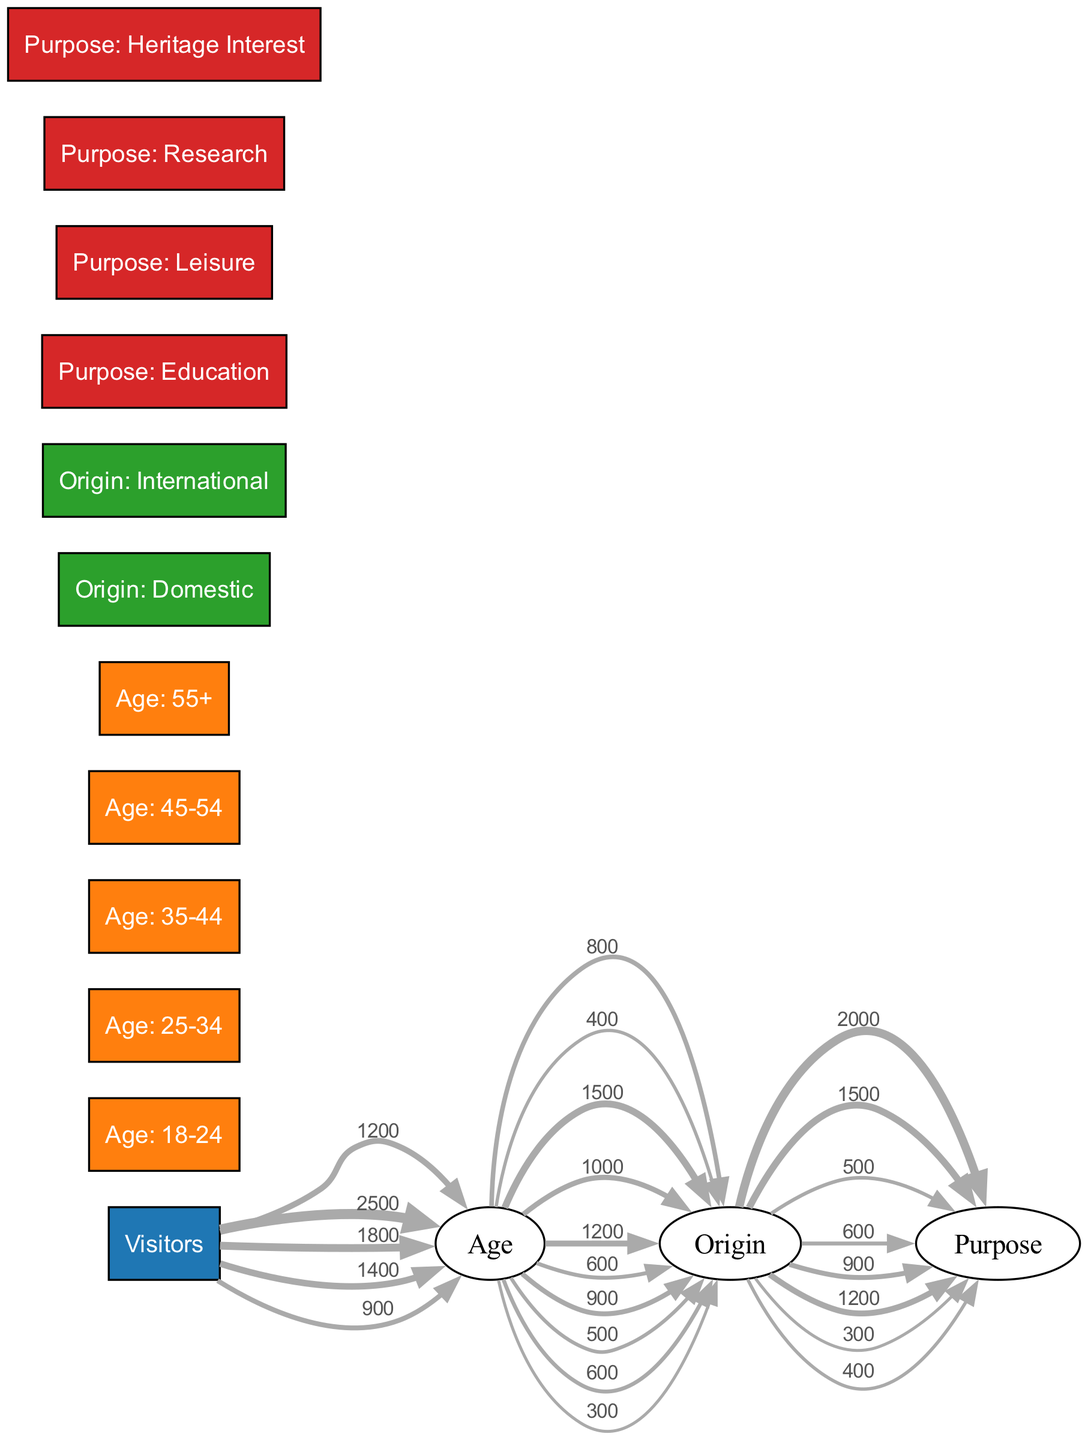What is the total number of visitors aged 25-34? The diagram shows a direct flow from the node "Visitors" to "Age: 25-34" with a value of 2500, indicating that this is the total number of visitors in this age range.
Answer: 2500 Which age group has the lowest number of visitors? By comparing the values linked to each age group node, "Age: 55+" has a value of 900, which is the smallest of all age groups.
Answer: Age: 55+ What percentage of visitors aged 18-24 are domestic? The node "Age: 18-24" has a split flow of 800 to "Origin: Domestic" and 400 to "Origin: International". Therefore, the percentage of domestic visitors in this age group is (800 / 1200) * 100 = 66.67%.
Answer: 66.67% What is the total number of visitors from international origin? Summing all visitors flowing from "Origin: International" gives 400 + 1000 + 600 + 500 = 2800, indicating that this is the total number of visitors from international origins.
Answer: 2800 Which purpose of visit is most common for domestic visitors? The highest value for the purpose of domestic visitors is "Purpose: Education" with a value of 2000, indicating that it is the most common purpose.
Answer: Purpose: Education What is the total value of all purposes for international visitors? Adding the values from "Origin: International" yields 900 + 1200 + 300 + 400 = 2800, indicating this is the total for all purposes of international visitors.
Answer: 2800 What is the ratio of leisure visits from domestic visitors compared to research purposes? For domestic visitors, "Purpose: Leisure" has a value of 1500, and "Purpose: Research" has a value of 500. The ratio is 1500:500, which simplifies to 3:1.
Answer: 3:1 Which age group has the highest international visitors? The age group "Age: 25-34" has the highest international visitors with a value of 1000, the highest flow to "Origin: International".
Answer: Age: 25-34 How many visitors aged 35-44 are there from domestic origin? From "Age: 35-44", the value flowing to "Origin: Domestic" is 1200, indicating this is the number of domestic visitors in this age group.
Answer: 1200 